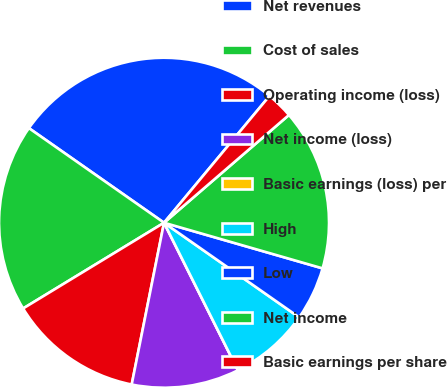Convert chart to OTSL. <chart><loc_0><loc_0><loc_500><loc_500><pie_chart><fcel>Net revenues<fcel>Cost of sales<fcel>Operating income (loss)<fcel>Net income (loss)<fcel>Basic earnings (loss) per<fcel>High<fcel>Low<fcel>Net income<fcel>Basic earnings per share<nl><fcel>26.32%<fcel>18.42%<fcel>13.16%<fcel>10.53%<fcel>0.0%<fcel>7.89%<fcel>5.26%<fcel>15.79%<fcel>2.63%<nl></chart> 